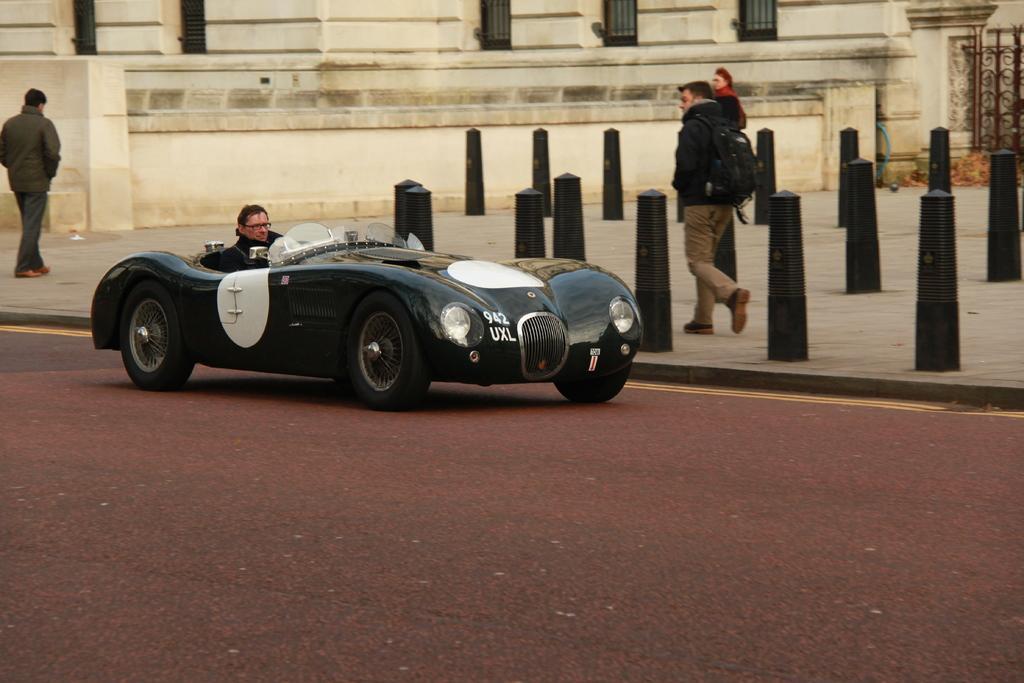Can you describe this image briefly? In this image i can see a car and the man in the car at the back ground i can see few people walking, building and a pole. 